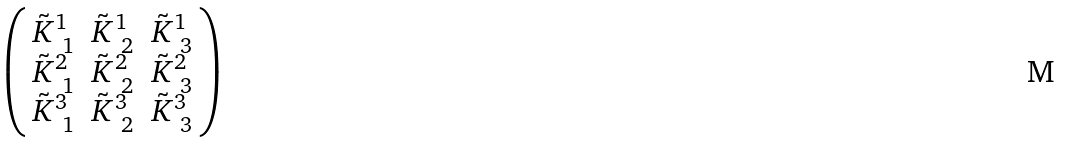Convert formula to latex. <formula><loc_0><loc_0><loc_500><loc_500>\begin{pmatrix} \, \tilde { K } ^ { 1 } _ { \ 1 } & \tilde { K } ^ { 1 } _ { \ 2 } & \tilde { K } ^ { 1 } _ { \ 3 } \, \\ \, \tilde { K } ^ { 2 } _ { \ 1 } & \tilde { K } ^ { 2 } _ { \ 2 } & \tilde { K } ^ { 2 } _ { \ 3 } \, \\ \, \tilde { K } ^ { 3 } _ { \ 1 } & \tilde { K } ^ { 3 } _ { \ 2 } & \tilde { K } ^ { 3 } _ { \ 3 } \, \end{pmatrix}</formula> 